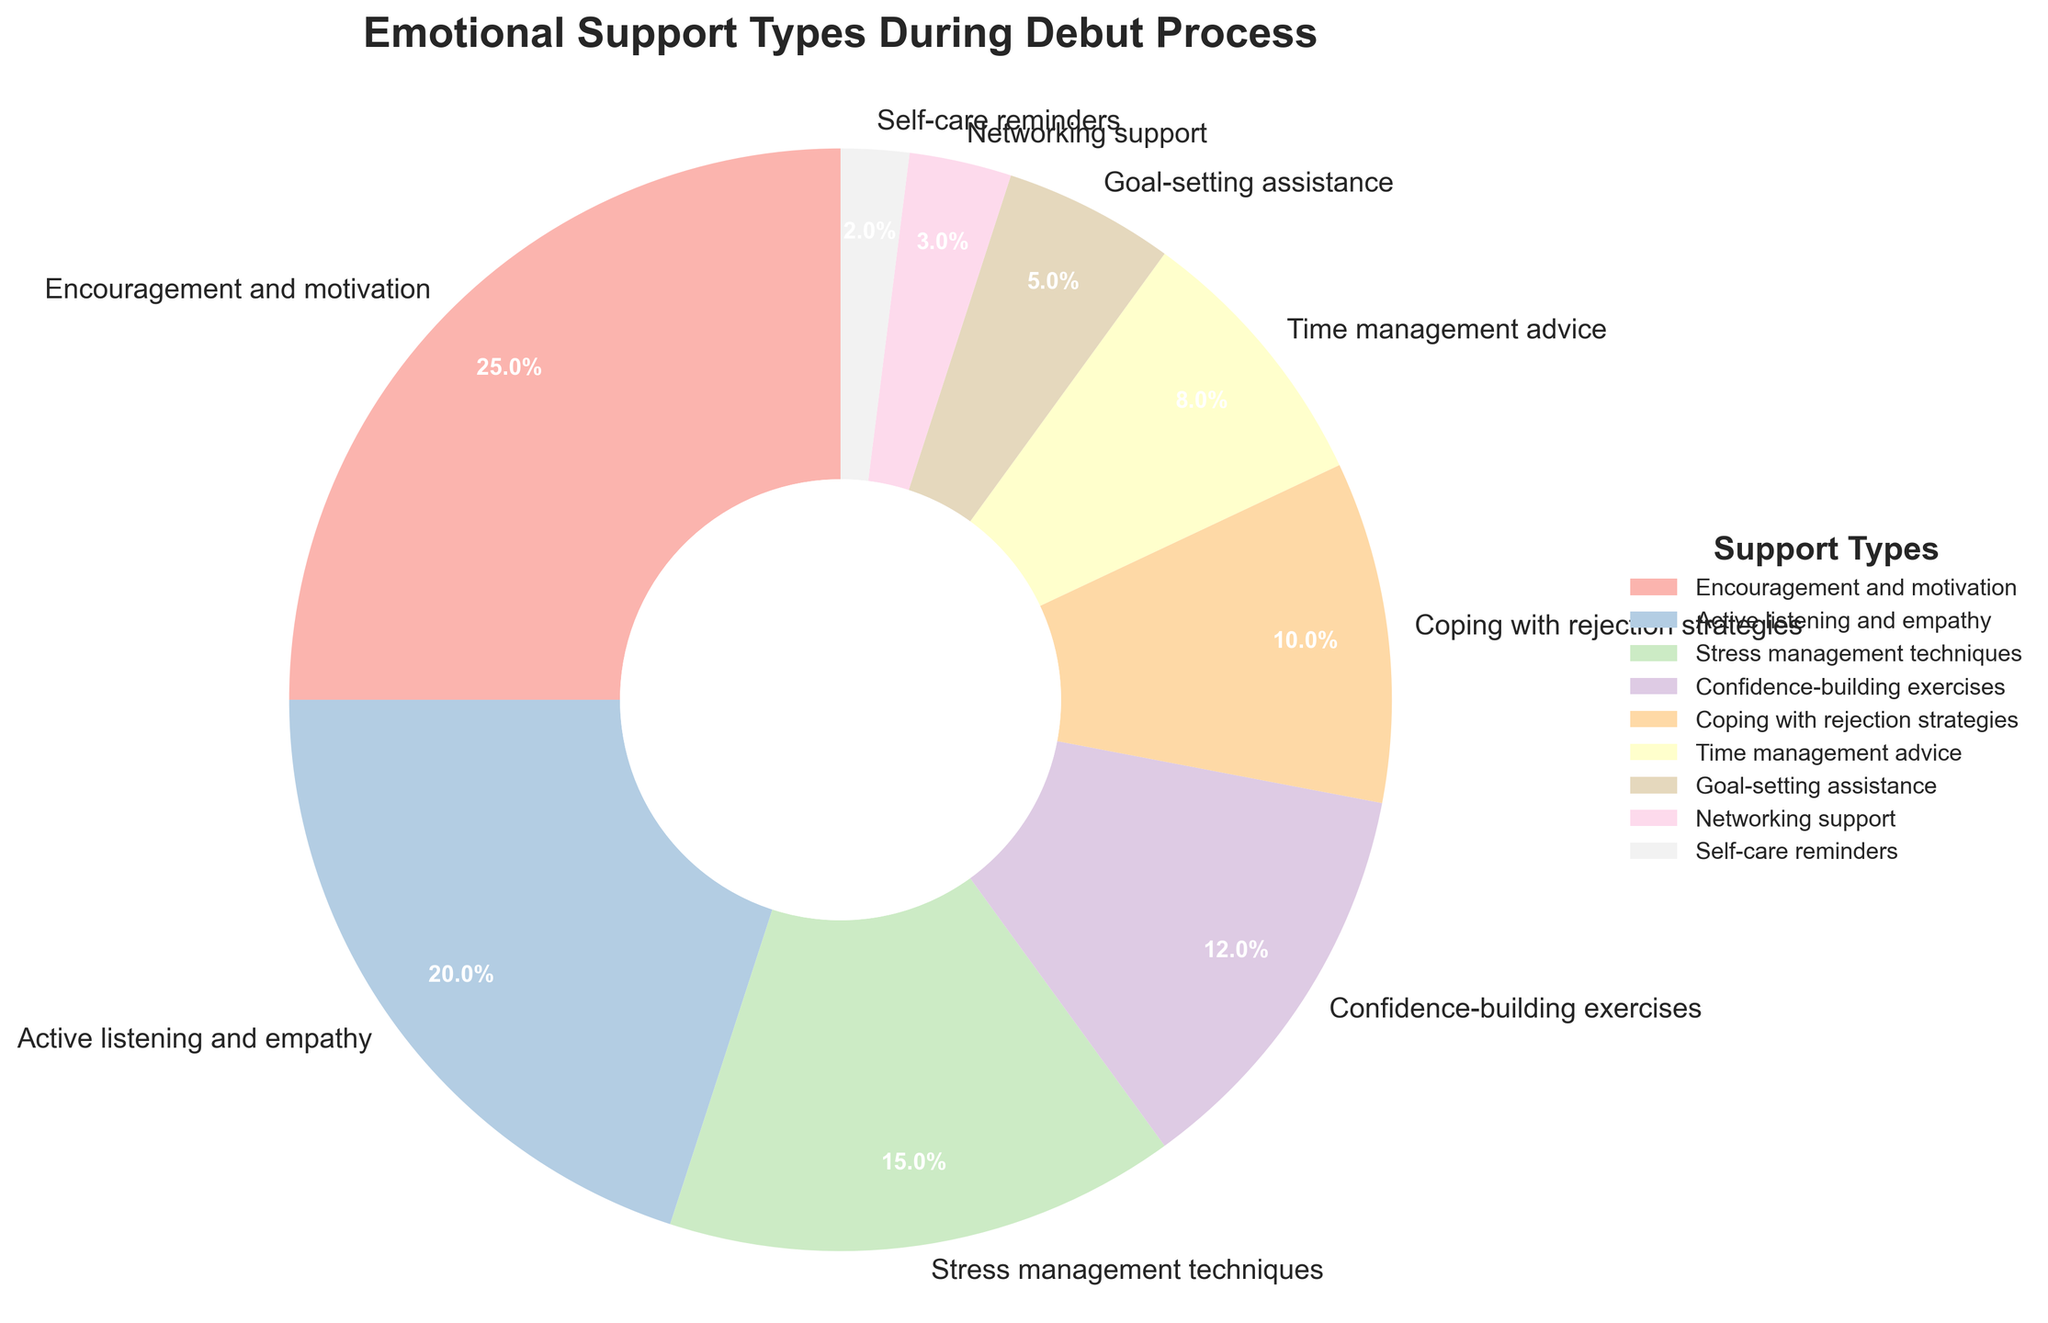Which category provides the highest percentage of emotional support during the debut process? By looking at the largest wedge in the pie chart, we can identify the category with the highest percentage.
Answer: Encouragement and motivation What is the combined percentage of 'Confidence-building exercises' and 'Coping with rejection strategies'? Add the percentages of 'Confidence-building exercises' (12%) and 'Coping with rejection strategies' (10%): 12 + 10 = 22.
Answer: 22% Which two categories have the smallest percentages of emotional support, and what are their combined values? Identify the two smallest wedges: 'Self-care reminders' (2%) and 'Networking support' (3%), then add their percentages: 2 + 3 = 5.
Answer: Self-care reminders and Networking support, 5% Is the percentage of 'Active listening and empathy' greater than that of 'Confidence-building exercises'? Compare the percentages: 'Active listening and empathy' is 20% and 'Confidence-building exercises' is 12%. Since 20 > 12, the answer is yes.
Answer: Yes What is the difference in percentage between 'Encouragement and motivation' and 'Time management advice'? Subtract the percentage of 'Time management advice' (8%) from 'Encouragement and motivation' (25%): 25 - 8 = 17.
Answer: 17% Which support types together make up more than half of the pie chart? Add the percentages until the sum exceeds 50%. 'Encouragement and motivation' (25%) + 'Active listening and empathy' (20%) = 45%, then add 'Stress management techniques' (15%): 45 + 15 = 60%.
Answer: Encouragement and motivation, Active listening and empathy, and Stress management techniques Are there more categories with percentages above 10% or below 10%? Count the categories above 10%: five (25%, 20%, 15%, 12%, 10%), and below 10%: four (8%, 5%, 3%, 2%). There are more categories above 10%.
Answer: Above 10% What is the average percentage of the categories 'Networking support', 'Self-care reminders', and 'Goal-setting assistance'? Add the percentages of 'Networking support' (3%), 'Self-care reminders' (2%), and 'Goal-setting assistance' (5%), then divide by 3: (3 + 2 + 5) / 3 = 10 / 3 ≈ 3.33.
Answer: 3.33% Which color represents 'Stress management techniques' in the chart? Identify the color of the wedge marked 'Stress management techniques'. This color corresponds to the third category in the figure.
Answer: (Color from spectrum, e.g., pastel pink or similar) What percentage of the support categories is made up of 'Coping with rejection strategies' plus 'Time management advice'? Add the percentages of 'Coping with rejection strategies' (10%) and 'Time management advice' (8%): 10 + 8 = 18.
Answer: 18% 